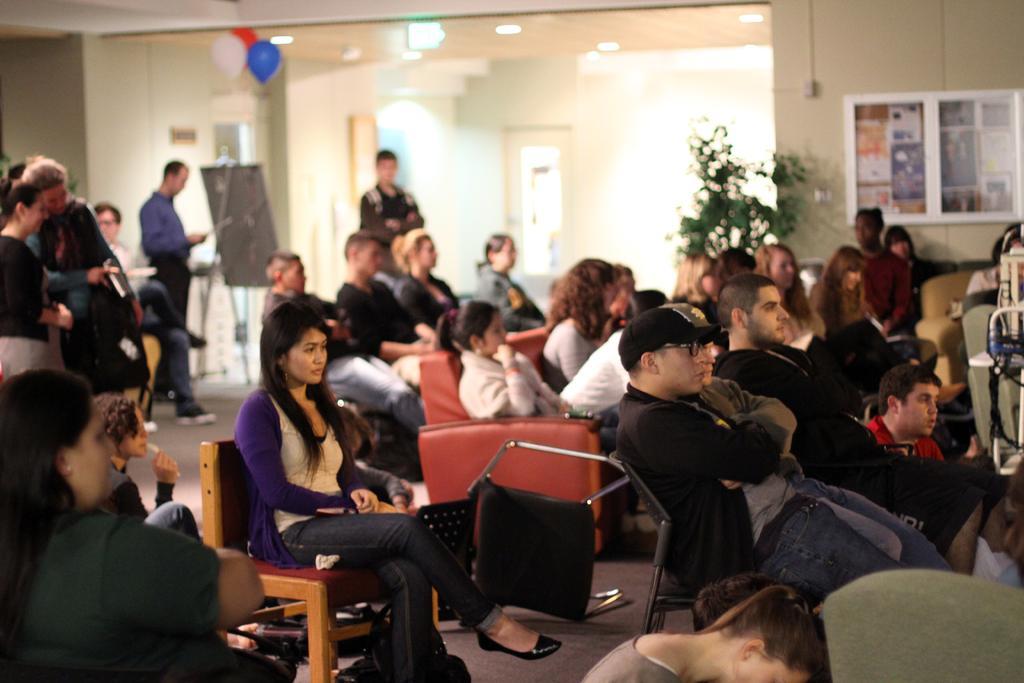In one or two sentences, can you explain what this image depicts? This picture might be taken inside the room. In this image, we can see group of people sitting on the chair. On the left side, we can also see three people are standing, we can also see a board. In the background, we can see some plants, balloons, boards. At the top, we can see a roof with few lights. 